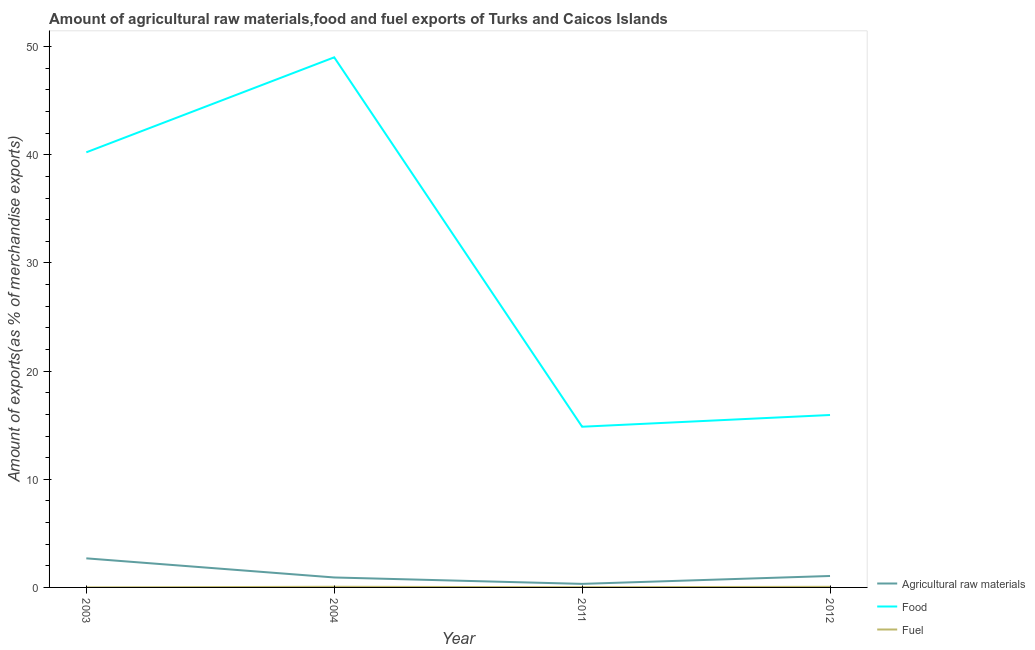How many different coloured lines are there?
Offer a terse response. 3. Is the number of lines equal to the number of legend labels?
Provide a succinct answer. Yes. What is the percentage of fuel exports in 2012?
Provide a succinct answer. 0.06. Across all years, what is the maximum percentage of raw materials exports?
Give a very brief answer. 2.69. Across all years, what is the minimum percentage of fuel exports?
Keep it short and to the point. 0. In which year was the percentage of food exports maximum?
Ensure brevity in your answer.  2004. What is the total percentage of fuel exports in the graph?
Provide a short and direct response. 0.14. What is the difference between the percentage of fuel exports in 2003 and that in 2012?
Your answer should be very brief. -0.05. What is the difference between the percentage of food exports in 2012 and the percentage of raw materials exports in 2004?
Keep it short and to the point. 15.02. What is the average percentage of raw materials exports per year?
Keep it short and to the point. 1.25. In the year 2003, what is the difference between the percentage of food exports and percentage of fuel exports?
Offer a terse response. 40.23. What is the ratio of the percentage of raw materials exports in 2003 to that in 2004?
Your answer should be very brief. 2.92. Is the percentage of fuel exports in 2011 less than that in 2012?
Provide a succinct answer. Yes. What is the difference between the highest and the second highest percentage of food exports?
Your answer should be compact. 8.78. What is the difference between the highest and the lowest percentage of raw materials exports?
Give a very brief answer. 2.36. Is it the case that in every year, the sum of the percentage of raw materials exports and percentage of food exports is greater than the percentage of fuel exports?
Offer a very short reply. Yes. Does the percentage of raw materials exports monotonically increase over the years?
Your answer should be very brief. No. Is the percentage of fuel exports strictly greater than the percentage of food exports over the years?
Provide a short and direct response. No. Is the percentage of raw materials exports strictly less than the percentage of food exports over the years?
Offer a very short reply. Yes. How many lines are there?
Your answer should be compact. 3. How many years are there in the graph?
Offer a terse response. 4. Are the values on the major ticks of Y-axis written in scientific E-notation?
Ensure brevity in your answer.  No. Does the graph contain any zero values?
Your answer should be compact. No. Does the graph contain grids?
Your answer should be very brief. No. How many legend labels are there?
Keep it short and to the point. 3. What is the title of the graph?
Make the answer very short. Amount of agricultural raw materials,food and fuel exports of Turks and Caicos Islands. What is the label or title of the Y-axis?
Your response must be concise. Amount of exports(as % of merchandise exports). What is the Amount of exports(as % of merchandise exports) of Agricultural raw materials in 2003?
Your answer should be compact. 2.69. What is the Amount of exports(as % of merchandise exports) of Food in 2003?
Your answer should be very brief. 40.23. What is the Amount of exports(as % of merchandise exports) in Fuel in 2003?
Offer a terse response. 0. What is the Amount of exports(as % of merchandise exports) of Agricultural raw materials in 2004?
Offer a terse response. 0.92. What is the Amount of exports(as % of merchandise exports) of Food in 2004?
Keep it short and to the point. 49.01. What is the Amount of exports(as % of merchandise exports) of Fuel in 2004?
Provide a succinct answer. 0.06. What is the Amount of exports(as % of merchandise exports) in Agricultural raw materials in 2011?
Give a very brief answer. 0.33. What is the Amount of exports(as % of merchandise exports) of Food in 2011?
Make the answer very short. 14.86. What is the Amount of exports(as % of merchandise exports) of Fuel in 2011?
Your answer should be compact. 0.02. What is the Amount of exports(as % of merchandise exports) in Agricultural raw materials in 2012?
Give a very brief answer. 1.06. What is the Amount of exports(as % of merchandise exports) of Food in 2012?
Keep it short and to the point. 15.94. What is the Amount of exports(as % of merchandise exports) in Fuel in 2012?
Keep it short and to the point. 0.06. Across all years, what is the maximum Amount of exports(as % of merchandise exports) in Agricultural raw materials?
Offer a terse response. 2.69. Across all years, what is the maximum Amount of exports(as % of merchandise exports) in Food?
Keep it short and to the point. 49.01. Across all years, what is the maximum Amount of exports(as % of merchandise exports) of Fuel?
Provide a succinct answer. 0.06. Across all years, what is the minimum Amount of exports(as % of merchandise exports) of Agricultural raw materials?
Your response must be concise. 0.33. Across all years, what is the minimum Amount of exports(as % of merchandise exports) in Food?
Offer a very short reply. 14.86. Across all years, what is the minimum Amount of exports(as % of merchandise exports) in Fuel?
Your answer should be compact. 0. What is the total Amount of exports(as % of merchandise exports) of Agricultural raw materials in the graph?
Give a very brief answer. 5. What is the total Amount of exports(as % of merchandise exports) of Food in the graph?
Your answer should be compact. 120.05. What is the total Amount of exports(as % of merchandise exports) of Fuel in the graph?
Offer a terse response. 0.14. What is the difference between the Amount of exports(as % of merchandise exports) in Agricultural raw materials in 2003 and that in 2004?
Ensure brevity in your answer.  1.77. What is the difference between the Amount of exports(as % of merchandise exports) in Food in 2003 and that in 2004?
Offer a terse response. -8.78. What is the difference between the Amount of exports(as % of merchandise exports) in Fuel in 2003 and that in 2004?
Provide a succinct answer. -0.06. What is the difference between the Amount of exports(as % of merchandise exports) in Agricultural raw materials in 2003 and that in 2011?
Provide a succinct answer. 2.36. What is the difference between the Amount of exports(as % of merchandise exports) in Food in 2003 and that in 2011?
Provide a succinct answer. 25.37. What is the difference between the Amount of exports(as % of merchandise exports) of Fuel in 2003 and that in 2011?
Give a very brief answer. -0.02. What is the difference between the Amount of exports(as % of merchandise exports) in Agricultural raw materials in 2003 and that in 2012?
Make the answer very short. 1.63. What is the difference between the Amount of exports(as % of merchandise exports) in Food in 2003 and that in 2012?
Provide a short and direct response. 24.29. What is the difference between the Amount of exports(as % of merchandise exports) of Fuel in 2003 and that in 2012?
Ensure brevity in your answer.  -0.05. What is the difference between the Amount of exports(as % of merchandise exports) in Agricultural raw materials in 2004 and that in 2011?
Offer a very short reply. 0.59. What is the difference between the Amount of exports(as % of merchandise exports) in Food in 2004 and that in 2011?
Your answer should be compact. 34.16. What is the difference between the Amount of exports(as % of merchandise exports) in Fuel in 2004 and that in 2011?
Provide a succinct answer. 0.04. What is the difference between the Amount of exports(as % of merchandise exports) of Agricultural raw materials in 2004 and that in 2012?
Provide a succinct answer. -0.14. What is the difference between the Amount of exports(as % of merchandise exports) of Food in 2004 and that in 2012?
Your response must be concise. 33.07. What is the difference between the Amount of exports(as % of merchandise exports) in Fuel in 2004 and that in 2012?
Offer a very short reply. 0. What is the difference between the Amount of exports(as % of merchandise exports) in Agricultural raw materials in 2011 and that in 2012?
Ensure brevity in your answer.  -0.73. What is the difference between the Amount of exports(as % of merchandise exports) of Food in 2011 and that in 2012?
Keep it short and to the point. -1.08. What is the difference between the Amount of exports(as % of merchandise exports) in Fuel in 2011 and that in 2012?
Offer a terse response. -0.04. What is the difference between the Amount of exports(as % of merchandise exports) in Agricultural raw materials in 2003 and the Amount of exports(as % of merchandise exports) in Food in 2004?
Your response must be concise. -46.33. What is the difference between the Amount of exports(as % of merchandise exports) in Agricultural raw materials in 2003 and the Amount of exports(as % of merchandise exports) in Fuel in 2004?
Keep it short and to the point. 2.63. What is the difference between the Amount of exports(as % of merchandise exports) in Food in 2003 and the Amount of exports(as % of merchandise exports) in Fuel in 2004?
Ensure brevity in your answer.  40.17. What is the difference between the Amount of exports(as % of merchandise exports) in Agricultural raw materials in 2003 and the Amount of exports(as % of merchandise exports) in Food in 2011?
Your response must be concise. -12.17. What is the difference between the Amount of exports(as % of merchandise exports) of Agricultural raw materials in 2003 and the Amount of exports(as % of merchandise exports) of Fuel in 2011?
Give a very brief answer. 2.67. What is the difference between the Amount of exports(as % of merchandise exports) in Food in 2003 and the Amount of exports(as % of merchandise exports) in Fuel in 2011?
Ensure brevity in your answer.  40.21. What is the difference between the Amount of exports(as % of merchandise exports) in Agricultural raw materials in 2003 and the Amount of exports(as % of merchandise exports) in Food in 2012?
Your answer should be compact. -13.25. What is the difference between the Amount of exports(as % of merchandise exports) in Agricultural raw materials in 2003 and the Amount of exports(as % of merchandise exports) in Fuel in 2012?
Ensure brevity in your answer.  2.63. What is the difference between the Amount of exports(as % of merchandise exports) of Food in 2003 and the Amount of exports(as % of merchandise exports) of Fuel in 2012?
Provide a succinct answer. 40.17. What is the difference between the Amount of exports(as % of merchandise exports) in Agricultural raw materials in 2004 and the Amount of exports(as % of merchandise exports) in Food in 2011?
Give a very brief answer. -13.94. What is the difference between the Amount of exports(as % of merchandise exports) of Agricultural raw materials in 2004 and the Amount of exports(as % of merchandise exports) of Fuel in 2011?
Ensure brevity in your answer.  0.9. What is the difference between the Amount of exports(as % of merchandise exports) of Food in 2004 and the Amount of exports(as % of merchandise exports) of Fuel in 2011?
Keep it short and to the point. 48.99. What is the difference between the Amount of exports(as % of merchandise exports) in Agricultural raw materials in 2004 and the Amount of exports(as % of merchandise exports) in Food in 2012?
Offer a terse response. -15.02. What is the difference between the Amount of exports(as % of merchandise exports) of Agricultural raw materials in 2004 and the Amount of exports(as % of merchandise exports) of Fuel in 2012?
Provide a succinct answer. 0.86. What is the difference between the Amount of exports(as % of merchandise exports) in Food in 2004 and the Amount of exports(as % of merchandise exports) in Fuel in 2012?
Ensure brevity in your answer.  48.96. What is the difference between the Amount of exports(as % of merchandise exports) in Agricultural raw materials in 2011 and the Amount of exports(as % of merchandise exports) in Food in 2012?
Offer a very short reply. -15.61. What is the difference between the Amount of exports(as % of merchandise exports) of Agricultural raw materials in 2011 and the Amount of exports(as % of merchandise exports) of Fuel in 2012?
Your response must be concise. 0.27. What is the difference between the Amount of exports(as % of merchandise exports) of Food in 2011 and the Amount of exports(as % of merchandise exports) of Fuel in 2012?
Offer a very short reply. 14.8. What is the average Amount of exports(as % of merchandise exports) of Agricultural raw materials per year?
Provide a short and direct response. 1.25. What is the average Amount of exports(as % of merchandise exports) of Food per year?
Offer a very short reply. 30.01. What is the average Amount of exports(as % of merchandise exports) of Fuel per year?
Provide a short and direct response. 0.04. In the year 2003, what is the difference between the Amount of exports(as % of merchandise exports) of Agricultural raw materials and Amount of exports(as % of merchandise exports) of Food?
Offer a terse response. -37.54. In the year 2003, what is the difference between the Amount of exports(as % of merchandise exports) of Agricultural raw materials and Amount of exports(as % of merchandise exports) of Fuel?
Give a very brief answer. 2.69. In the year 2003, what is the difference between the Amount of exports(as % of merchandise exports) of Food and Amount of exports(as % of merchandise exports) of Fuel?
Give a very brief answer. 40.23. In the year 2004, what is the difference between the Amount of exports(as % of merchandise exports) of Agricultural raw materials and Amount of exports(as % of merchandise exports) of Food?
Make the answer very short. -48.09. In the year 2004, what is the difference between the Amount of exports(as % of merchandise exports) in Agricultural raw materials and Amount of exports(as % of merchandise exports) in Fuel?
Your response must be concise. 0.86. In the year 2004, what is the difference between the Amount of exports(as % of merchandise exports) in Food and Amount of exports(as % of merchandise exports) in Fuel?
Provide a short and direct response. 48.95. In the year 2011, what is the difference between the Amount of exports(as % of merchandise exports) of Agricultural raw materials and Amount of exports(as % of merchandise exports) of Food?
Make the answer very short. -14.53. In the year 2011, what is the difference between the Amount of exports(as % of merchandise exports) of Agricultural raw materials and Amount of exports(as % of merchandise exports) of Fuel?
Your response must be concise. 0.31. In the year 2011, what is the difference between the Amount of exports(as % of merchandise exports) of Food and Amount of exports(as % of merchandise exports) of Fuel?
Offer a very short reply. 14.84. In the year 2012, what is the difference between the Amount of exports(as % of merchandise exports) in Agricultural raw materials and Amount of exports(as % of merchandise exports) in Food?
Keep it short and to the point. -14.88. In the year 2012, what is the difference between the Amount of exports(as % of merchandise exports) in Agricultural raw materials and Amount of exports(as % of merchandise exports) in Fuel?
Offer a terse response. 1. In the year 2012, what is the difference between the Amount of exports(as % of merchandise exports) in Food and Amount of exports(as % of merchandise exports) in Fuel?
Ensure brevity in your answer.  15.89. What is the ratio of the Amount of exports(as % of merchandise exports) of Agricultural raw materials in 2003 to that in 2004?
Your answer should be very brief. 2.92. What is the ratio of the Amount of exports(as % of merchandise exports) of Food in 2003 to that in 2004?
Your answer should be compact. 0.82. What is the ratio of the Amount of exports(as % of merchandise exports) of Fuel in 2003 to that in 2004?
Ensure brevity in your answer.  0.05. What is the ratio of the Amount of exports(as % of merchandise exports) of Agricultural raw materials in 2003 to that in 2011?
Offer a terse response. 8.17. What is the ratio of the Amount of exports(as % of merchandise exports) in Food in 2003 to that in 2011?
Make the answer very short. 2.71. What is the ratio of the Amount of exports(as % of merchandise exports) in Fuel in 2003 to that in 2011?
Your answer should be very brief. 0.14. What is the ratio of the Amount of exports(as % of merchandise exports) in Agricultural raw materials in 2003 to that in 2012?
Provide a short and direct response. 2.54. What is the ratio of the Amount of exports(as % of merchandise exports) of Food in 2003 to that in 2012?
Offer a terse response. 2.52. What is the ratio of the Amount of exports(as % of merchandise exports) of Fuel in 2003 to that in 2012?
Give a very brief answer. 0.05. What is the ratio of the Amount of exports(as % of merchandise exports) in Agricultural raw materials in 2004 to that in 2011?
Make the answer very short. 2.8. What is the ratio of the Amount of exports(as % of merchandise exports) in Food in 2004 to that in 2011?
Make the answer very short. 3.3. What is the ratio of the Amount of exports(as % of merchandise exports) of Fuel in 2004 to that in 2011?
Your answer should be very brief. 2.71. What is the ratio of the Amount of exports(as % of merchandise exports) in Agricultural raw materials in 2004 to that in 2012?
Provide a short and direct response. 0.87. What is the ratio of the Amount of exports(as % of merchandise exports) in Food in 2004 to that in 2012?
Your response must be concise. 3.07. What is the ratio of the Amount of exports(as % of merchandise exports) of Fuel in 2004 to that in 2012?
Make the answer very short. 1.04. What is the ratio of the Amount of exports(as % of merchandise exports) of Agricultural raw materials in 2011 to that in 2012?
Ensure brevity in your answer.  0.31. What is the ratio of the Amount of exports(as % of merchandise exports) of Food in 2011 to that in 2012?
Your response must be concise. 0.93. What is the ratio of the Amount of exports(as % of merchandise exports) of Fuel in 2011 to that in 2012?
Provide a succinct answer. 0.38. What is the difference between the highest and the second highest Amount of exports(as % of merchandise exports) of Agricultural raw materials?
Offer a terse response. 1.63. What is the difference between the highest and the second highest Amount of exports(as % of merchandise exports) of Food?
Your answer should be compact. 8.78. What is the difference between the highest and the second highest Amount of exports(as % of merchandise exports) of Fuel?
Provide a succinct answer. 0. What is the difference between the highest and the lowest Amount of exports(as % of merchandise exports) of Agricultural raw materials?
Ensure brevity in your answer.  2.36. What is the difference between the highest and the lowest Amount of exports(as % of merchandise exports) in Food?
Your answer should be very brief. 34.16. What is the difference between the highest and the lowest Amount of exports(as % of merchandise exports) in Fuel?
Make the answer very short. 0.06. 